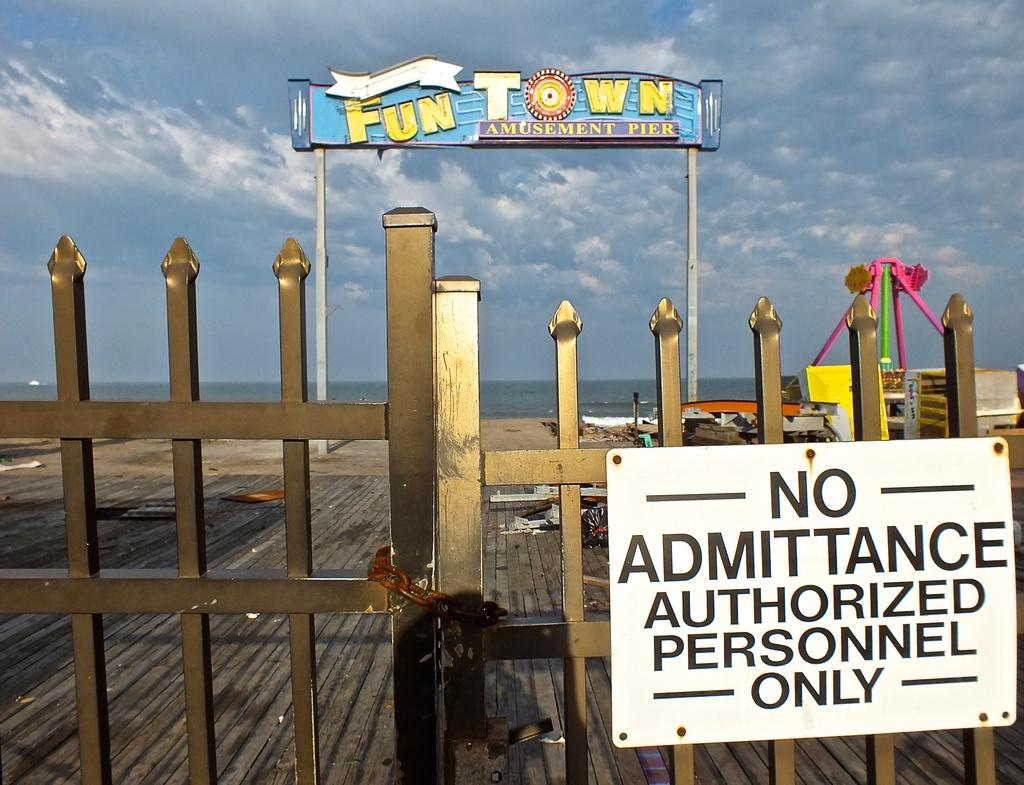<image>
Offer a succinct explanation of the picture presented. The closed and locked entrance to FunTown amusement park. 